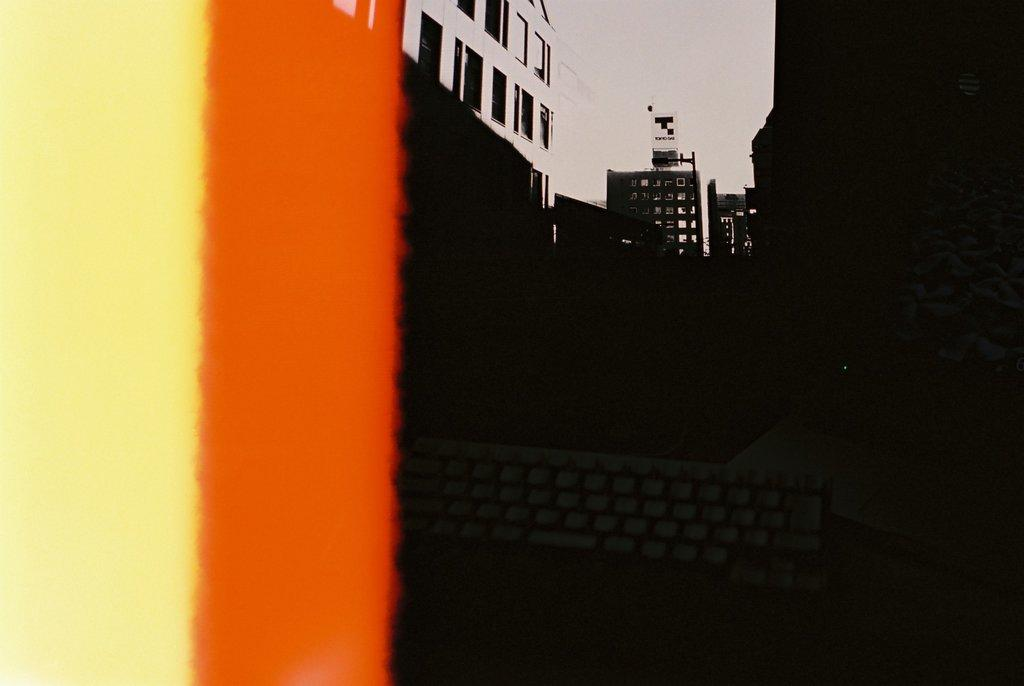What type of structures can be seen in the background of the image? There are buildings in the background of the image. What is visible at the top of the image? The sky is visible at the top of the image. How many dimes can be seen on the roof of the building in the image? There are no dimes visible in the image; it only shows buildings and the sky. What type of writing instrument is being used by the quill in the image? There is no quill present in the image. 